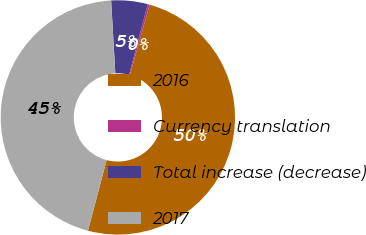<chart> <loc_0><loc_0><loc_500><loc_500><pie_chart><fcel>2016<fcel>Currency translation<fcel>Total increase (decrease)<fcel>2017<nl><fcel>49.73%<fcel>0.27%<fcel>5.02%<fcel>44.98%<nl></chart> 